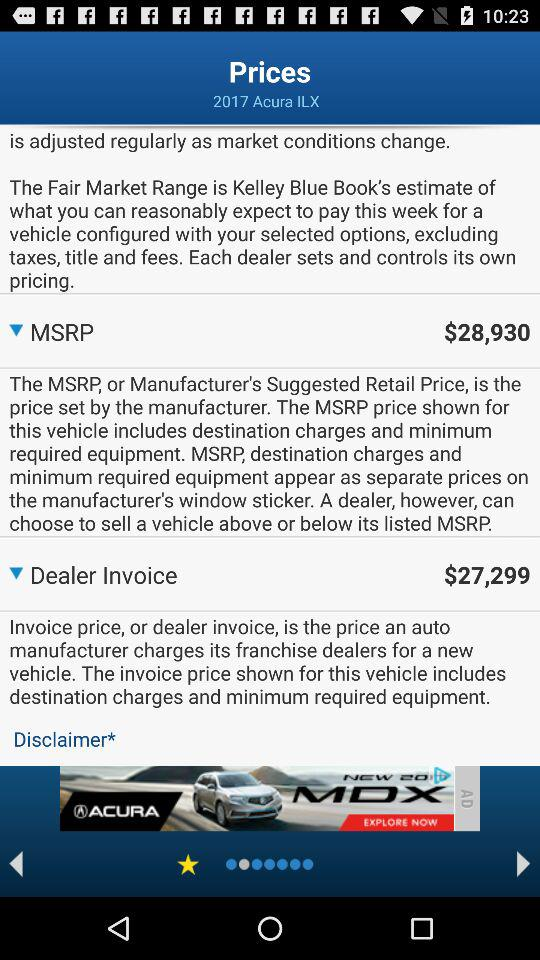What is the difference in price between the MSRP and the Dealer Invoice?
Answer the question using a single word or phrase. $1631 